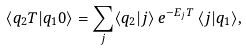<formula> <loc_0><loc_0><loc_500><loc_500>\langle q _ { 2 } T | q _ { 1 } 0 \rangle = \sum _ { j } \langle q _ { 2 } | j \rangle \, e ^ { - E _ { j } T } \, \langle j | q _ { 1 } \rangle ,</formula> 